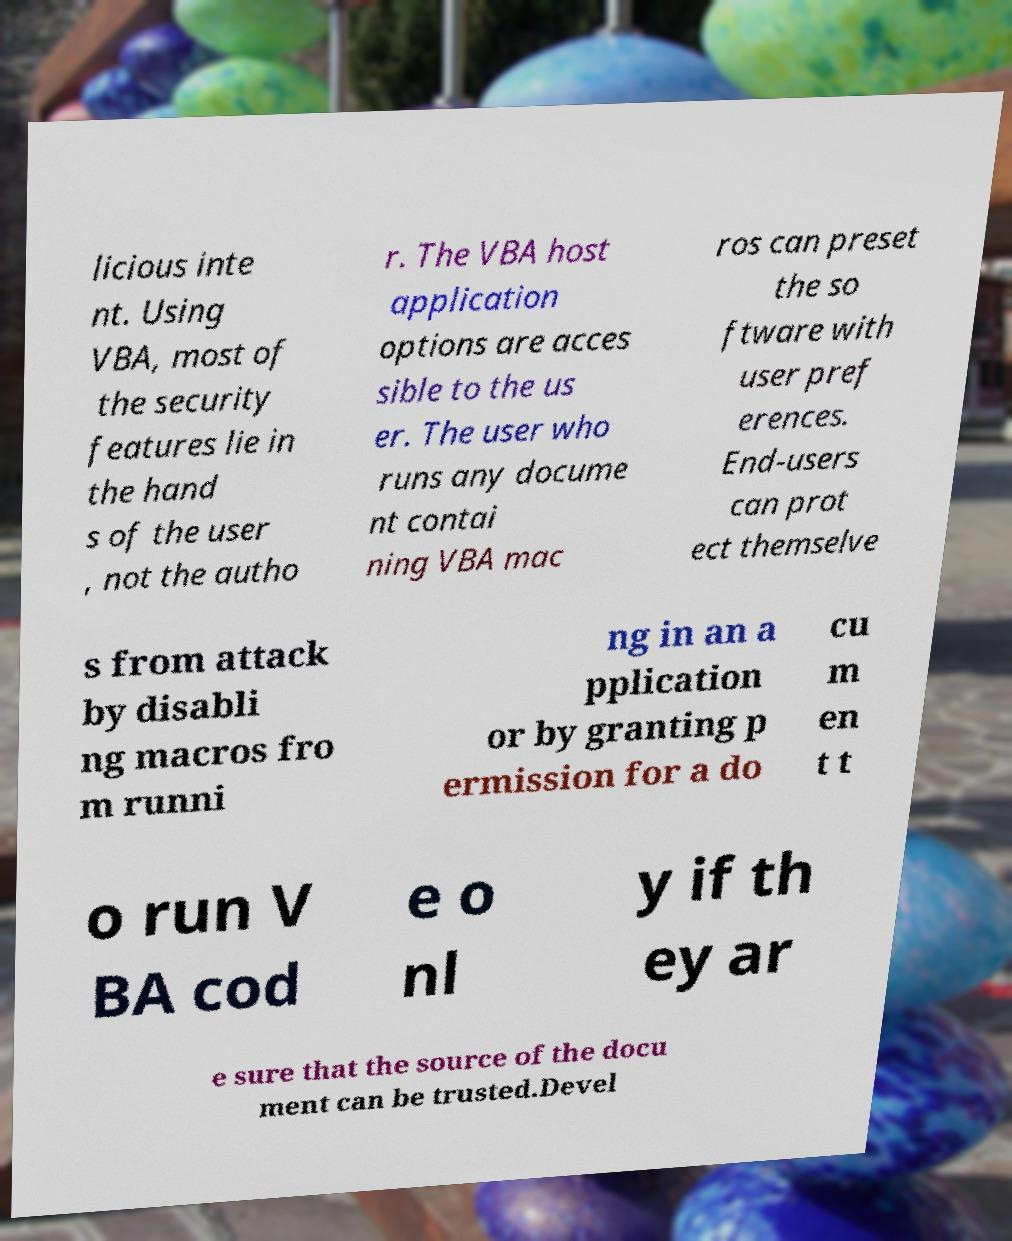Please read and relay the text visible in this image. What does it say? licious inte nt. Using VBA, most of the security features lie in the hand s of the user , not the autho r. The VBA host application options are acces sible to the us er. The user who runs any docume nt contai ning VBA mac ros can preset the so ftware with user pref erences. End-users can prot ect themselve s from attack by disabli ng macros fro m runni ng in an a pplication or by granting p ermission for a do cu m en t t o run V BA cod e o nl y if th ey ar e sure that the source of the docu ment can be trusted.Devel 